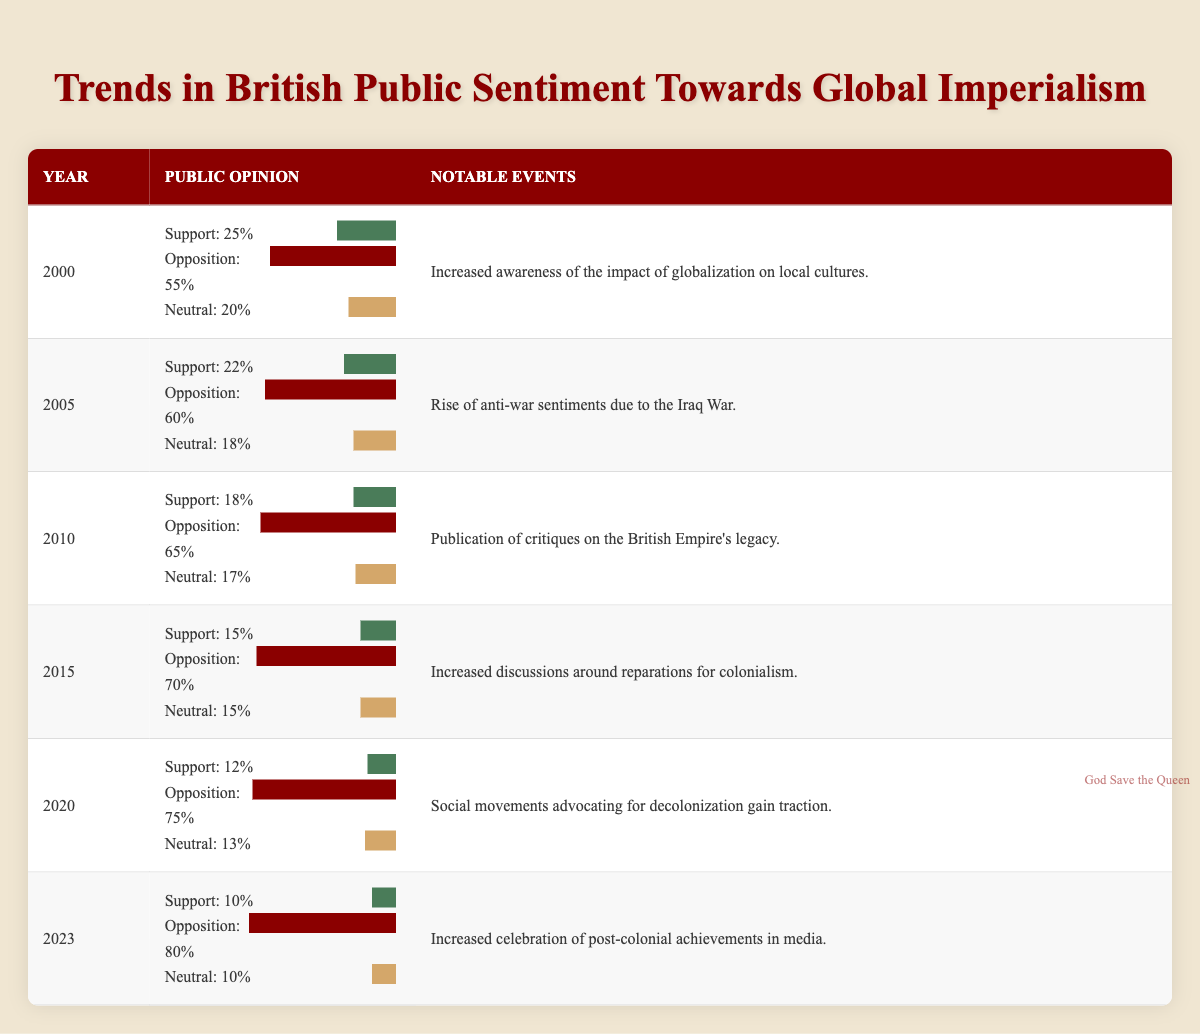What percentage of the British public supported imperialism in 2015? According to the table, in 2015, the percentage of the public that supported imperialism was 15%.
Answer: 15% What was the opposition percentage to imperialism in 2010? From the table, it is noted that in 2010, the opposition to imperialism was 65%.
Answer: 65% In which year did the opposition to imperialism first exceed 70%? Looking through the table, the opposition percentage exceeds 70% in 2015 (70%) and remains higher in subsequent years.
Answer: 2015 What is the average percentage of support for imperialism from 2000 to 2023? To find the average support percentage, we add the support percentages: (25 + 22 + 18 + 15 + 12 + 10) = 112, and divide by the total number of years (6), which results in 112 / 6 = 18.67, rounded to 19.
Answer: 19 Was there an increase in public opposition to imperialism from 2005 to 2010? From the table, in 2005 the opposition was 60%, and in 2010 it increased to 65%, indicating a rise in opposition during this period.
Answer: Yes What notable event in 2020 relates to public sentiment around imperialism? The table indicates that in 2020, social movements advocating for decolonization gained traction, which reflects an increase in public sentiment against imperialism.
Answer: Social movements advocating for decolonization gain traction How much did the public support for imperialism decline from 2000 to 2023? The support in 2000 was 25% and in 2023 it was 10%. To find the decline, we calculate 25 - 10 = 15%. Thus, the support for imperialism declined by 15%.
Answer: 15% What was the notable event in 2015 concerning discussions around colonialism? In 2015, there were increased discussions around reparations for colonialism, as noted in the table.
Answer: Increased discussions around reparations for colonialism What percentage of the public was neutral on the issue of imperialism in 2023? According to the table, the percentage of the public that was neutral on imperialism in 2023 was 10%.
Answer: 10% 